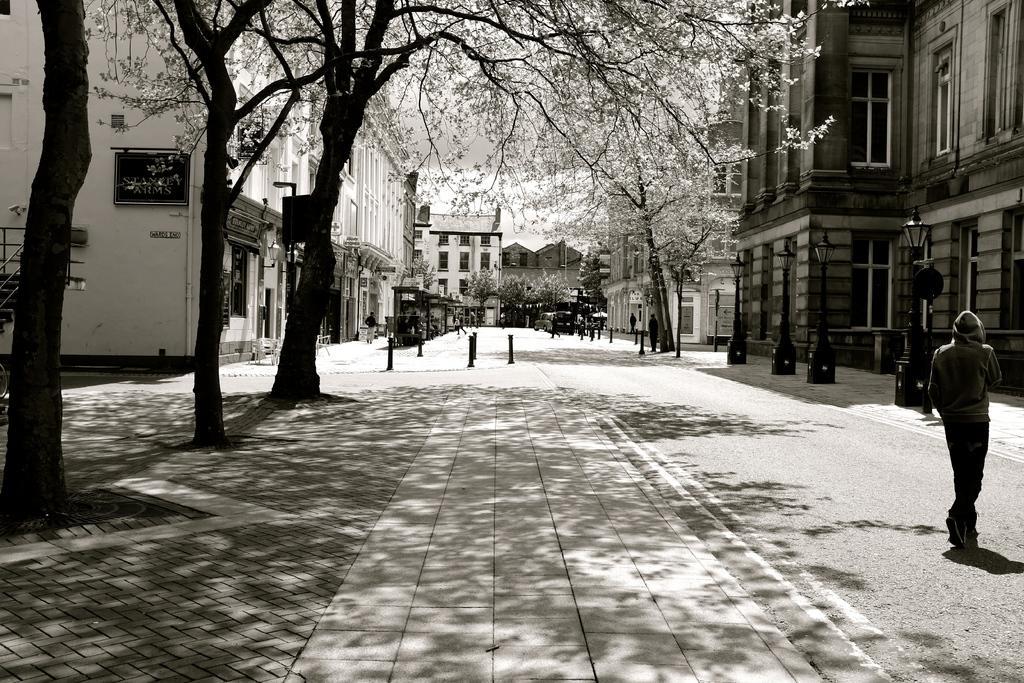Please provide a concise description of this image. In this image there is the sky towards the top of the image, there are buildings, there is a wall towards the left of the image, there is a board on the wall, there is text on the board, there are trees towards the top of the image, there is road towards the bottom of the image, there are objects on the road, there are persons walking on the road, there are vehicles on the road, there is a man walking towards the right of the image, there are poles, there are streetlights, there are windows. 